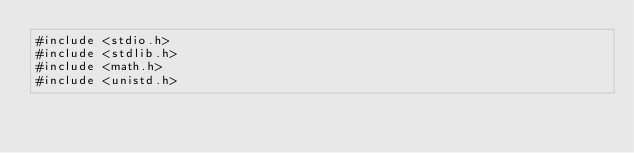<code> <loc_0><loc_0><loc_500><loc_500><_Cuda_>#include <stdio.h>
#include <stdlib.h>
#include <math.h>
#include <unistd.h>
</code> 